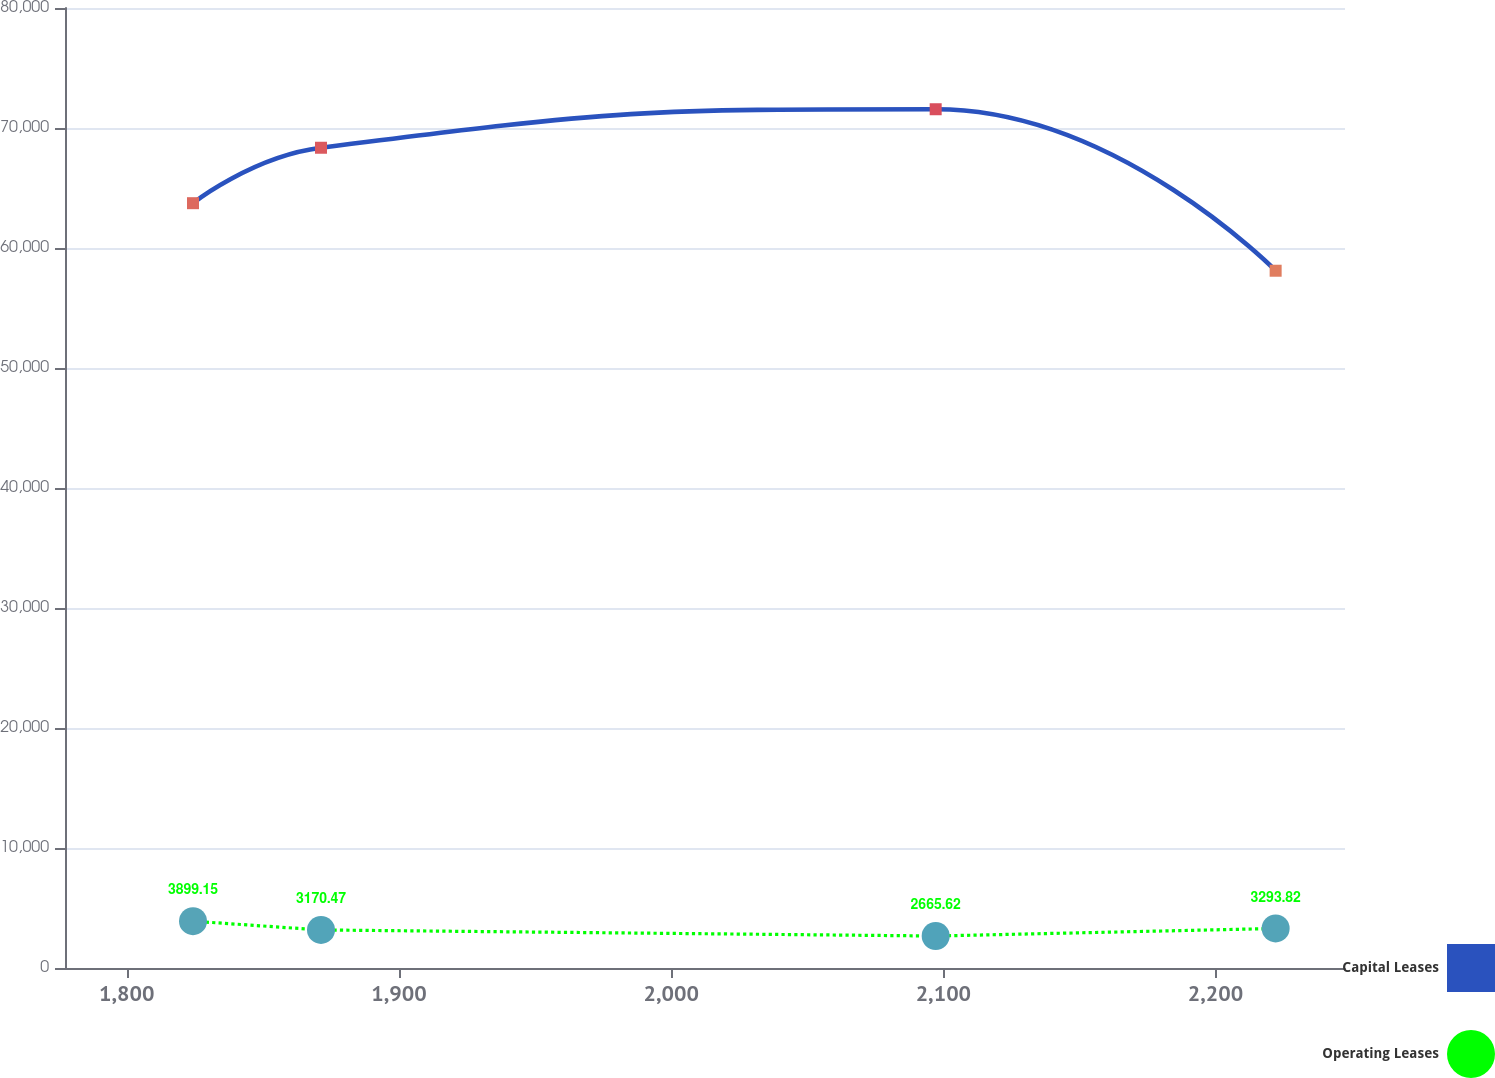Convert chart to OTSL. <chart><loc_0><loc_0><loc_500><loc_500><line_chart><ecel><fcel>Capital Leases<fcel>Operating Leases<nl><fcel>1824.35<fcel>63734.4<fcel>3899.15<nl><fcel>1871.37<fcel>68354.1<fcel>3170.47<nl><fcel>2097.18<fcel>71563.3<fcel>2665.62<nl><fcel>2222.07<fcel>58106<fcel>3293.82<nl><fcel>2294.57<fcel>36820.6<fcel>2788.97<nl></chart> 